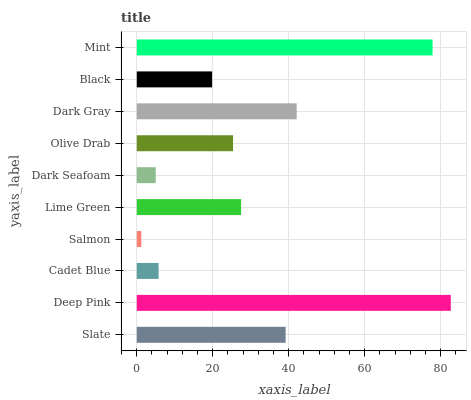Is Salmon the minimum?
Answer yes or no. Yes. Is Deep Pink the maximum?
Answer yes or no. Yes. Is Cadet Blue the minimum?
Answer yes or no. No. Is Cadet Blue the maximum?
Answer yes or no. No. Is Deep Pink greater than Cadet Blue?
Answer yes or no. Yes. Is Cadet Blue less than Deep Pink?
Answer yes or no. Yes. Is Cadet Blue greater than Deep Pink?
Answer yes or no. No. Is Deep Pink less than Cadet Blue?
Answer yes or no. No. Is Lime Green the high median?
Answer yes or no. Yes. Is Olive Drab the low median?
Answer yes or no. Yes. Is Dark Seafoam the high median?
Answer yes or no. No. Is Lime Green the low median?
Answer yes or no. No. 